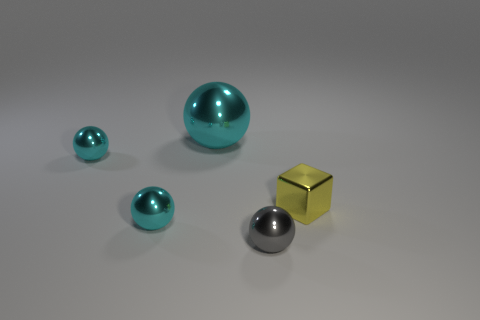Subtract all cyan balls. How many were subtracted if there are1cyan balls left? 2 Subtract all big spheres. How many spheres are left? 3 Subtract all green cylinders. How many cyan balls are left? 3 Add 5 tiny cyan balls. How many objects exist? 10 Subtract all gray spheres. How many spheres are left? 3 Subtract 2 spheres. How many spheres are left? 2 Subtract all purple spheres. Subtract all cyan cylinders. How many spheres are left? 4 Subtract 0 red spheres. How many objects are left? 5 Subtract all blocks. How many objects are left? 4 Subtract all large red matte objects. Subtract all cyan metallic spheres. How many objects are left? 2 